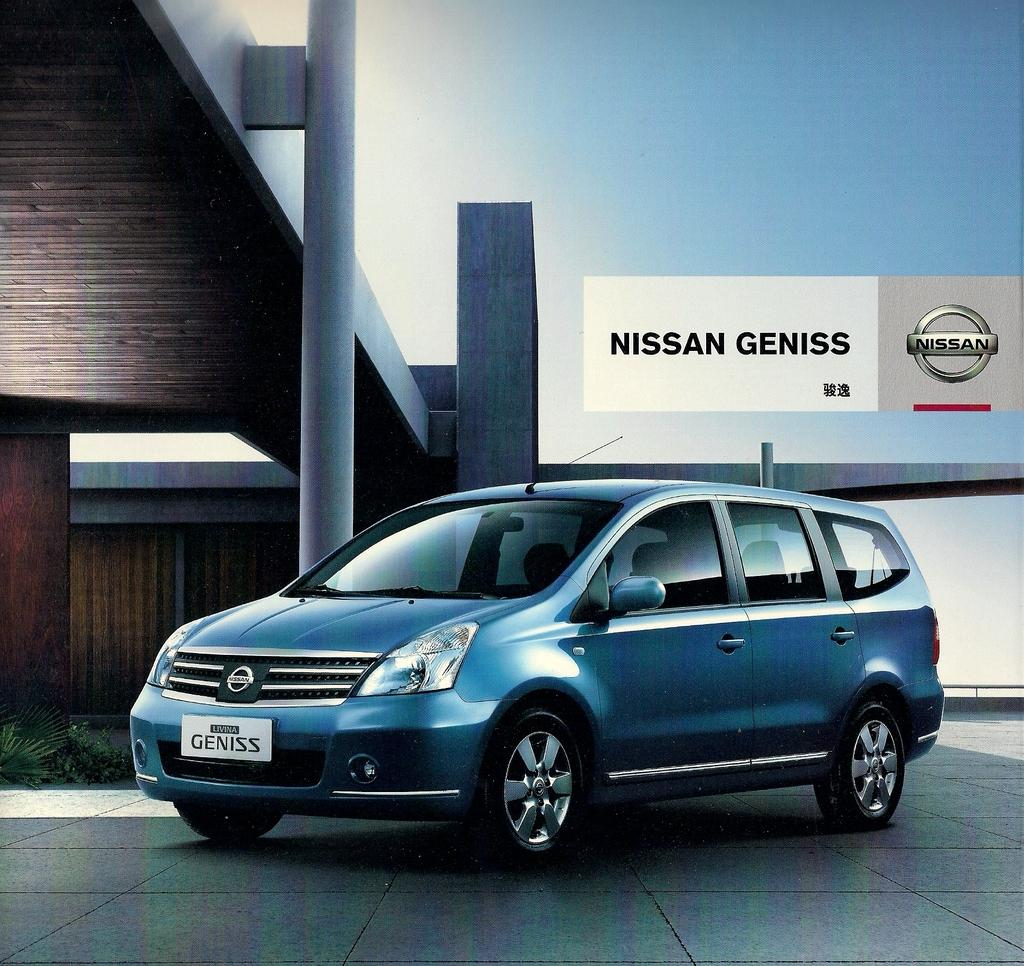<image>
Render a clear and concise summary of the photo. An ad for the Nissan Genesis new minivan. 